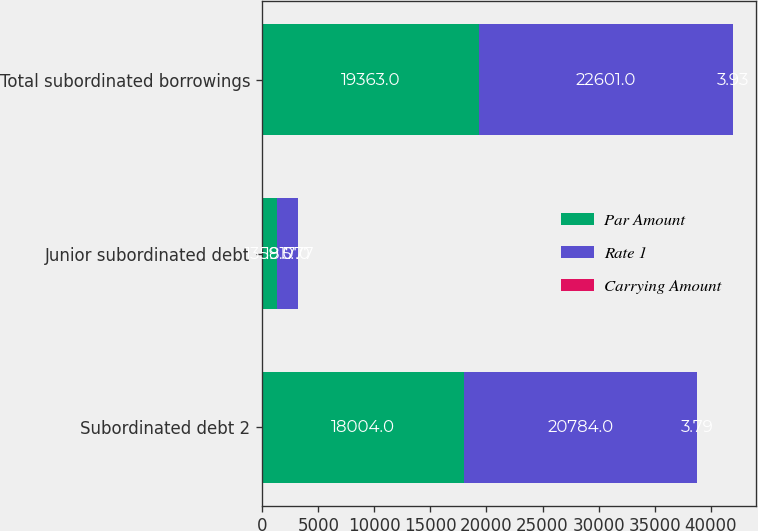Convert chart. <chart><loc_0><loc_0><loc_500><loc_500><stacked_bar_chart><ecel><fcel>Subordinated debt 2<fcel>Junior subordinated debt<fcel>Total subordinated borrowings<nl><fcel>Par Amount<fcel>18004<fcel>1359<fcel>19363<nl><fcel>Rate 1<fcel>20784<fcel>1817<fcel>22601<nl><fcel>Carrying Amount<fcel>3.79<fcel>5.77<fcel>3.93<nl></chart> 